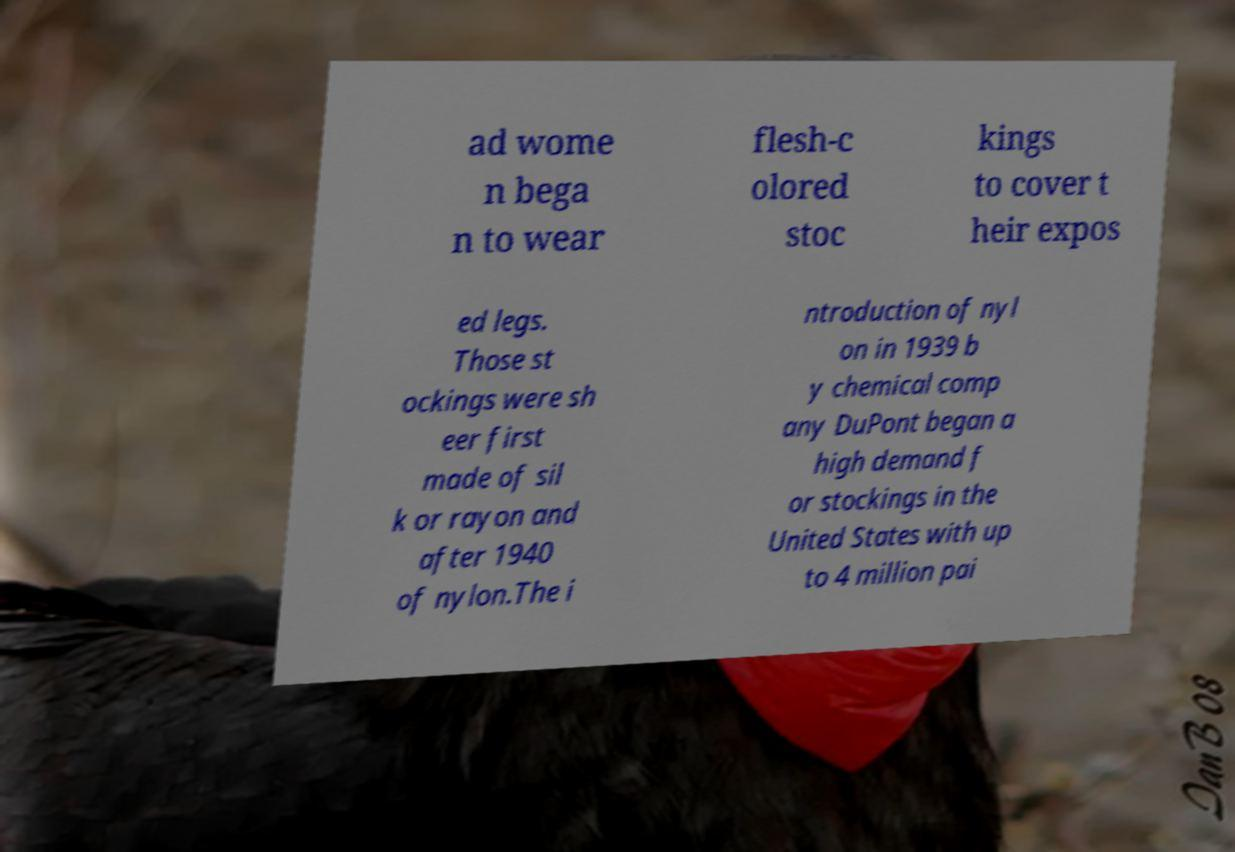Can you accurately transcribe the text from the provided image for me? ad wome n bega n to wear flesh-c olored stoc kings to cover t heir expos ed legs. Those st ockings were sh eer first made of sil k or rayon and after 1940 of nylon.The i ntroduction of nyl on in 1939 b y chemical comp any DuPont began a high demand f or stockings in the United States with up to 4 million pai 